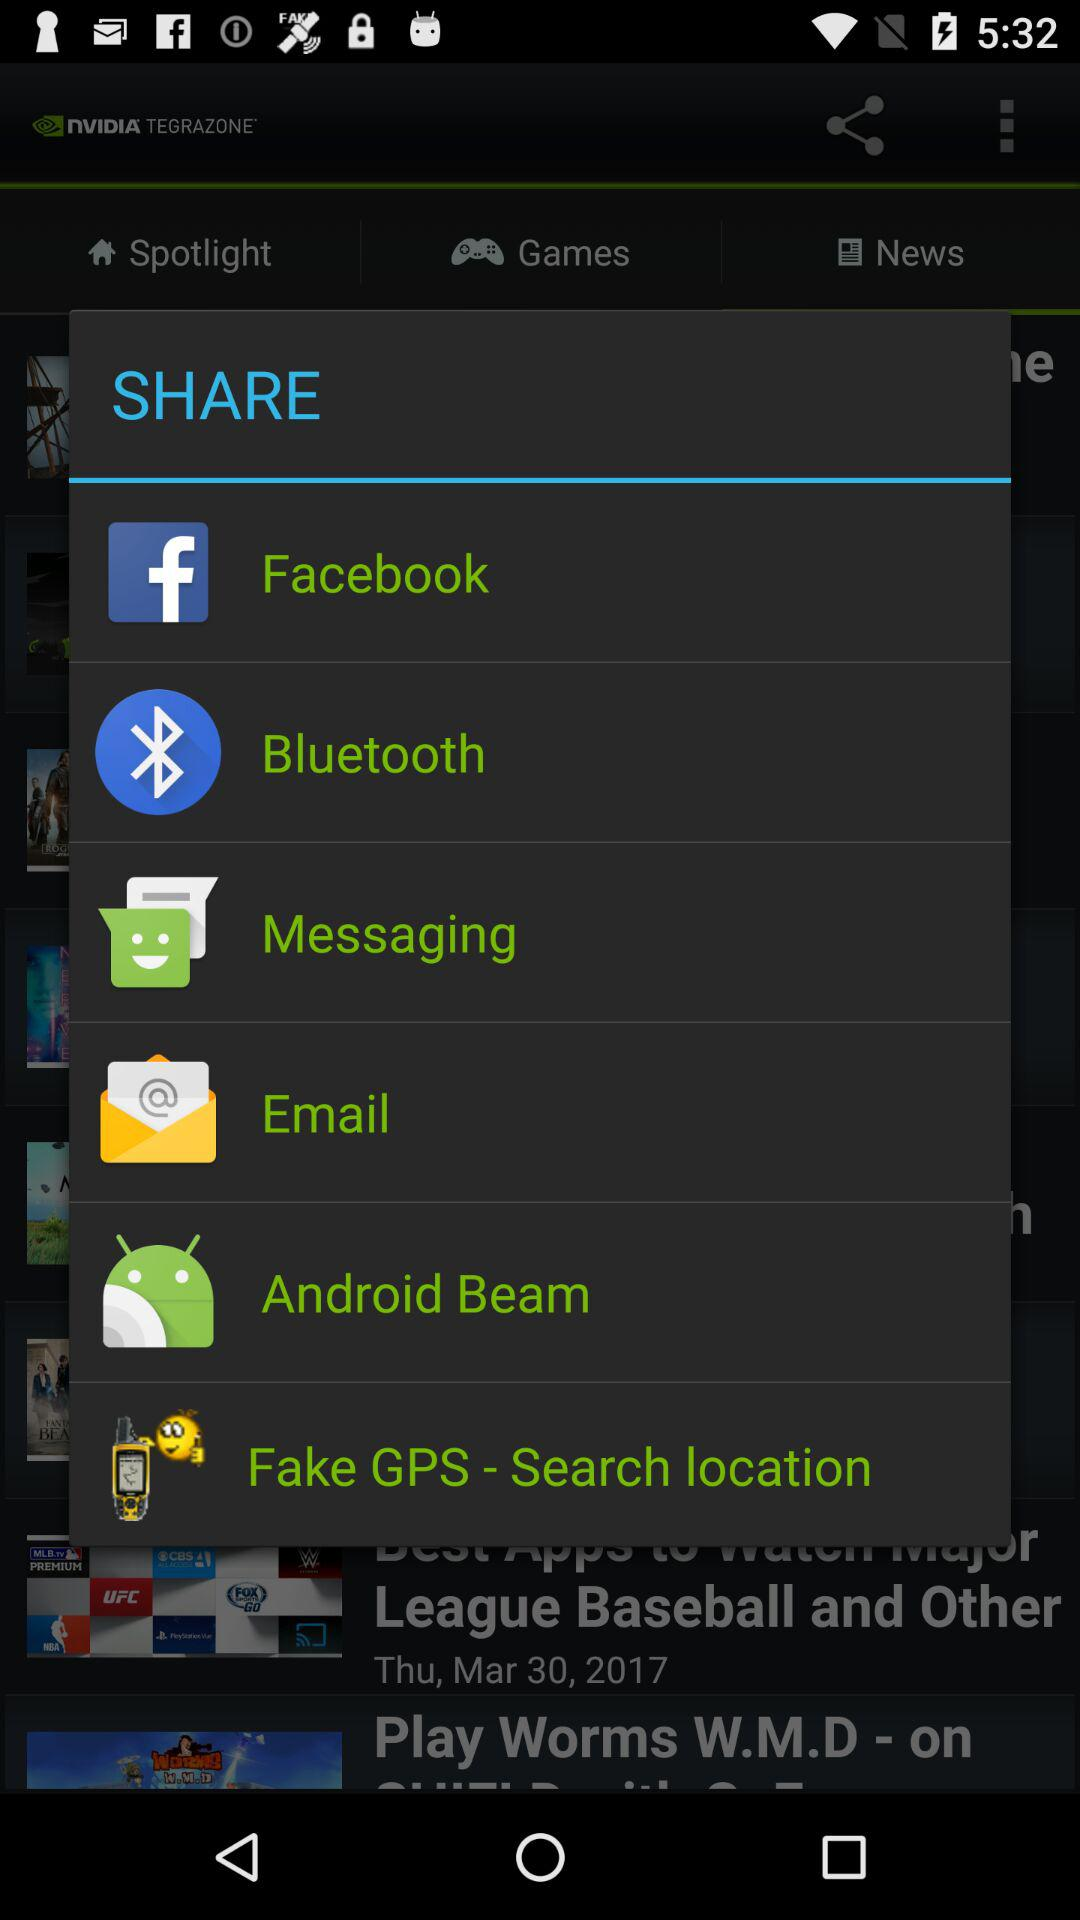What options are given to share? The applications are "Facebook", "Bluetooth", "Messaging", "Email", "Android Beam", and "Fake GPS-Search location". 